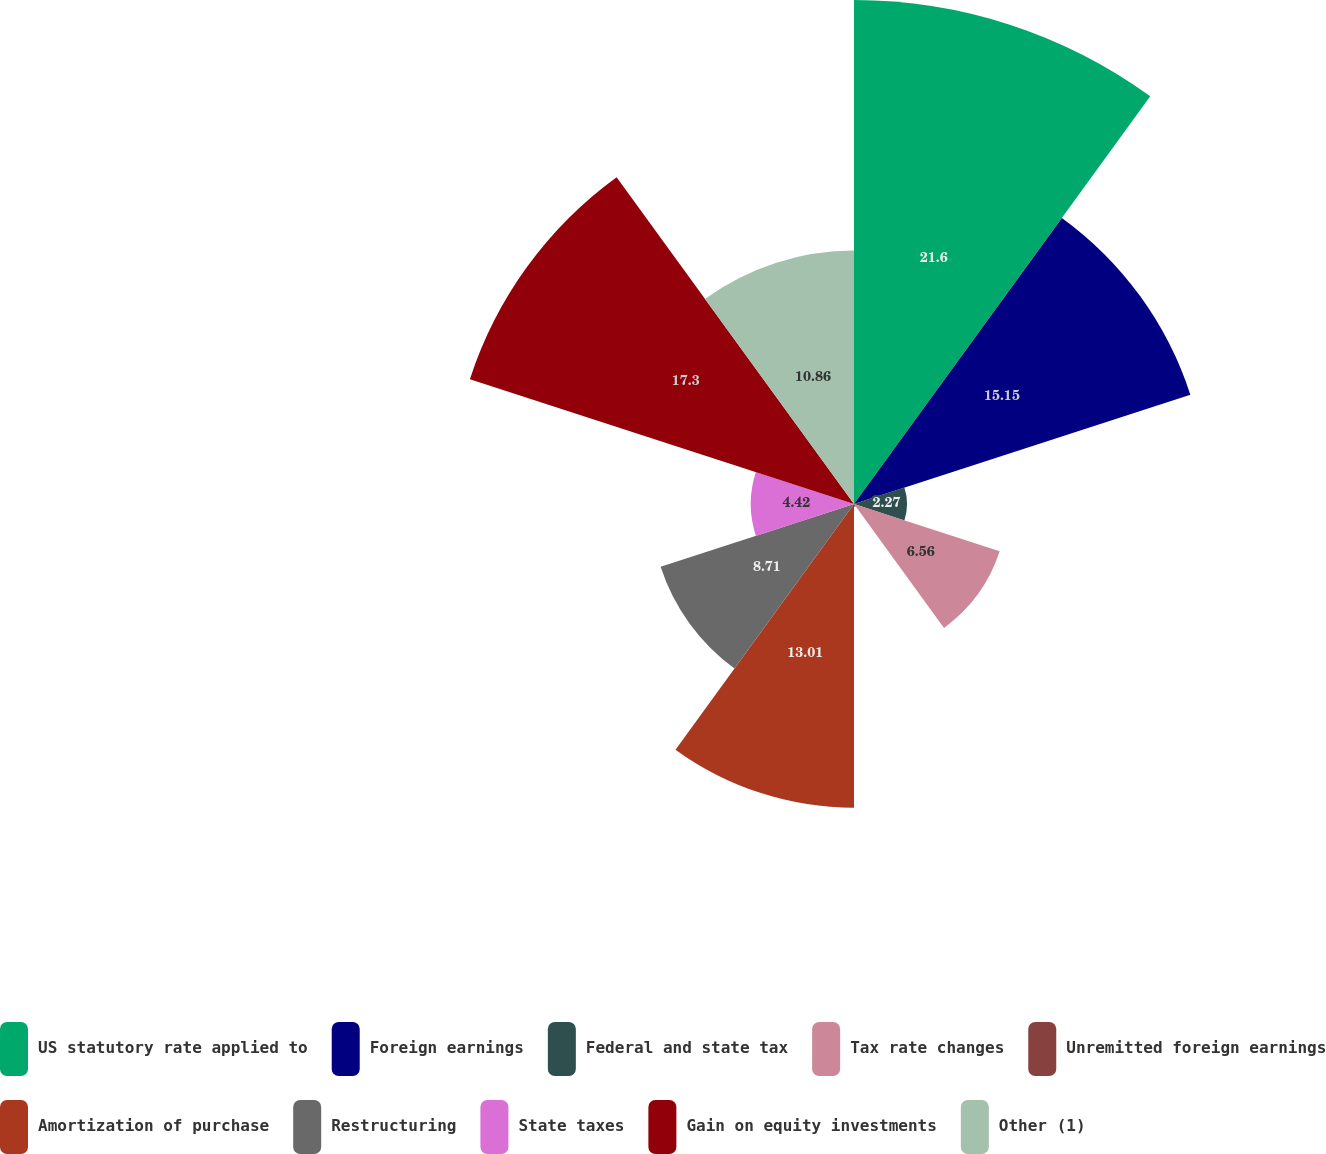Convert chart. <chart><loc_0><loc_0><loc_500><loc_500><pie_chart><fcel>US statutory rate applied to<fcel>Foreign earnings<fcel>Federal and state tax<fcel>Tax rate changes<fcel>Unremitted foreign earnings<fcel>Amortization of purchase<fcel>Restructuring<fcel>State taxes<fcel>Gain on equity investments<fcel>Other (1)<nl><fcel>21.59%<fcel>15.15%<fcel>2.27%<fcel>6.56%<fcel>0.12%<fcel>13.01%<fcel>8.71%<fcel>4.42%<fcel>17.3%<fcel>10.86%<nl></chart> 